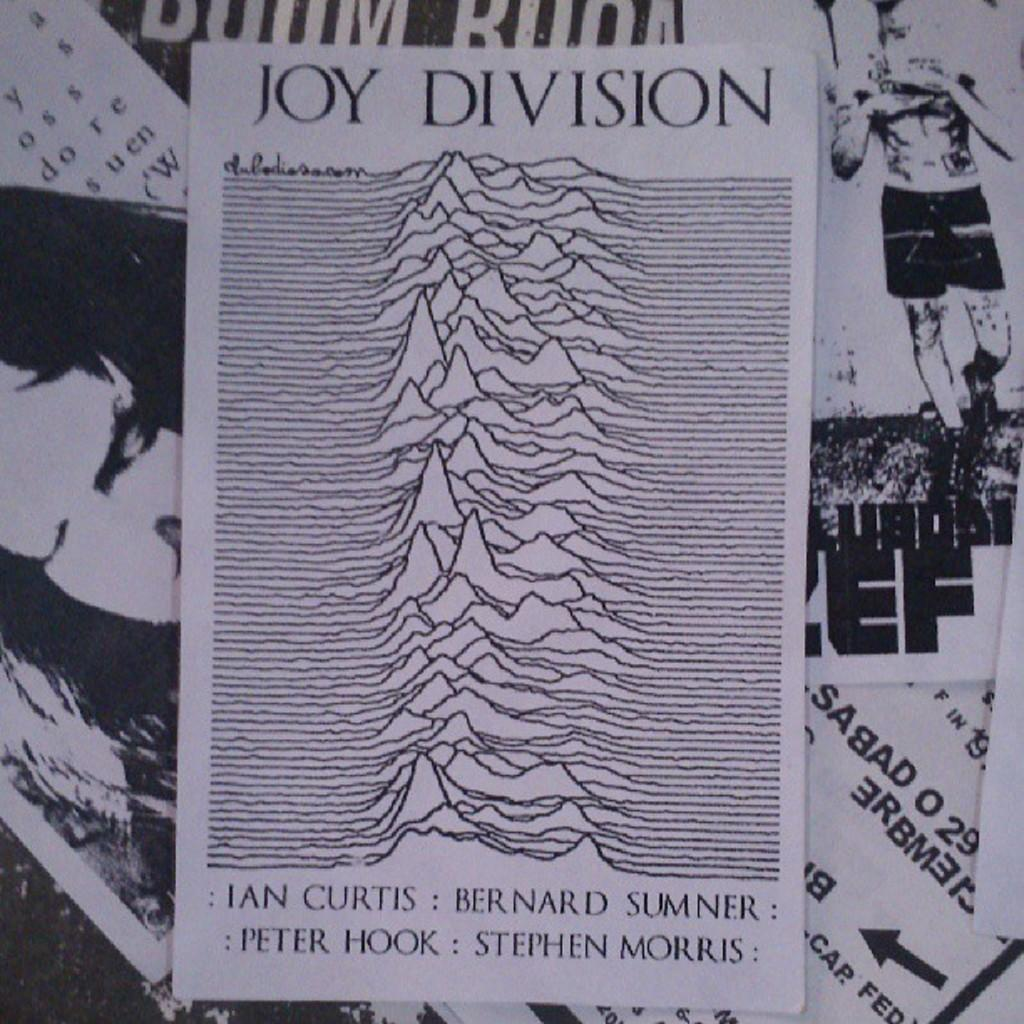<image>
Render a clear and concise summary of the photo. The poster that is shown is titled Joy Division. 